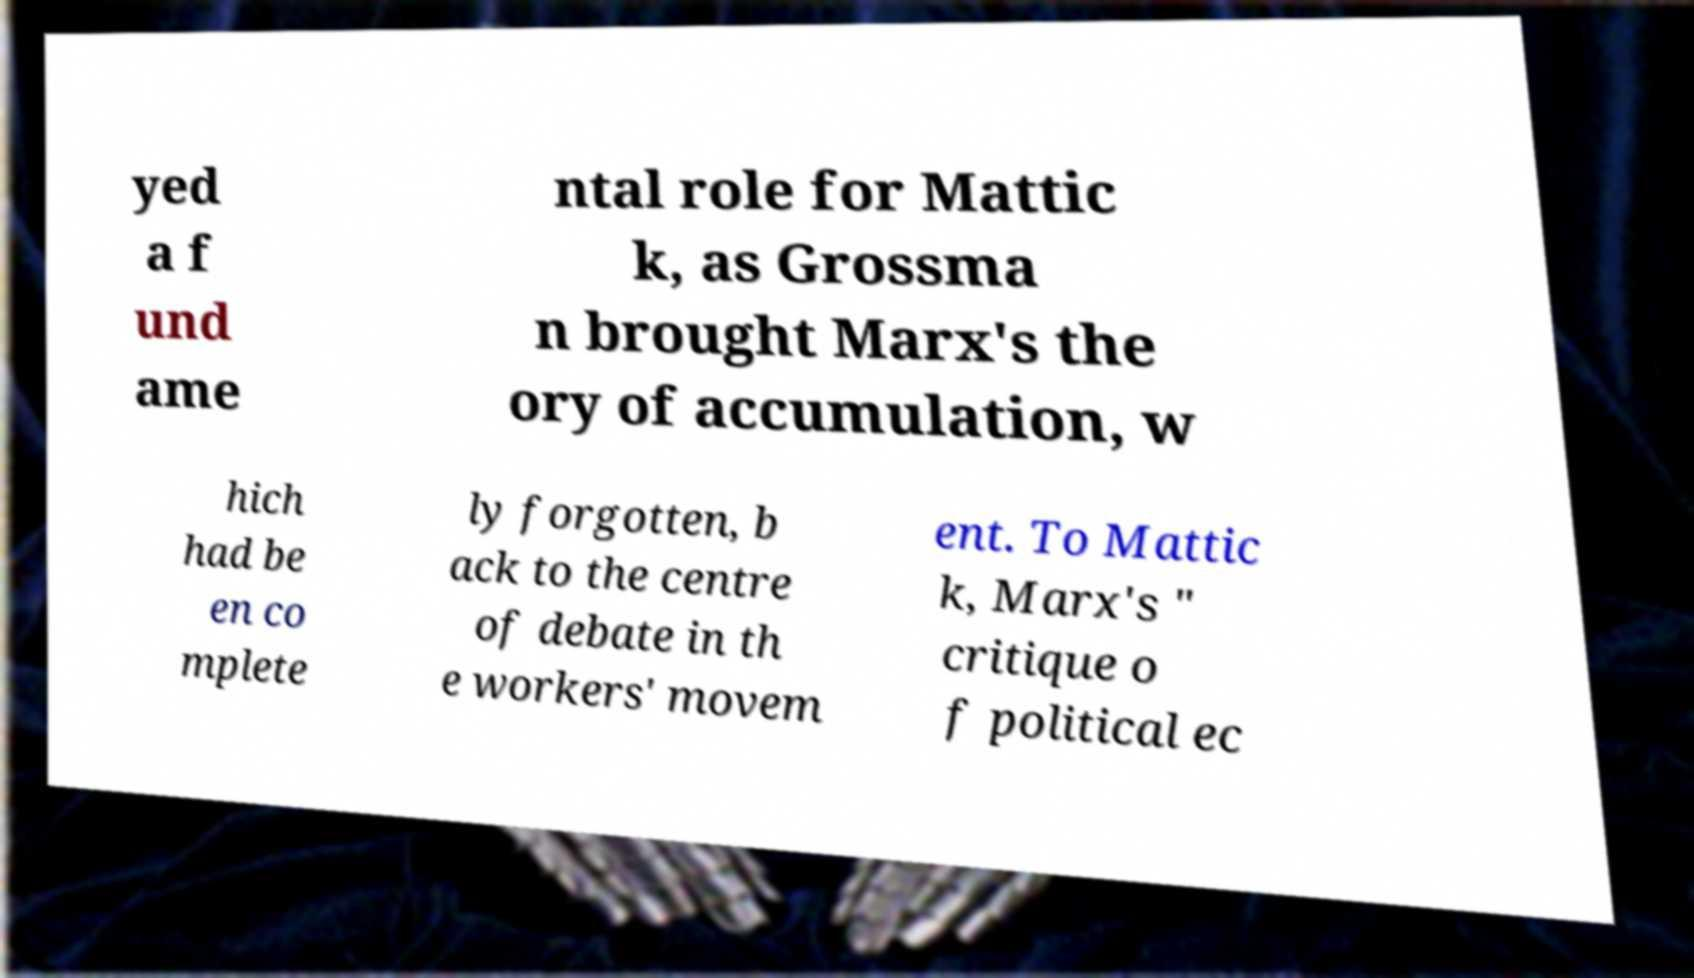Can you read and provide the text displayed in the image?This photo seems to have some interesting text. Can you extract and type it out for me? yed a f und ame ntal role for Mattic k, as Grossma n brought Marx's the ory of accumulation, w hich had be en co mplete ly forgotten, b ack to the centre of debate in th e workers' movem ent. To Mattic k, Marx's " critique o f political ec 